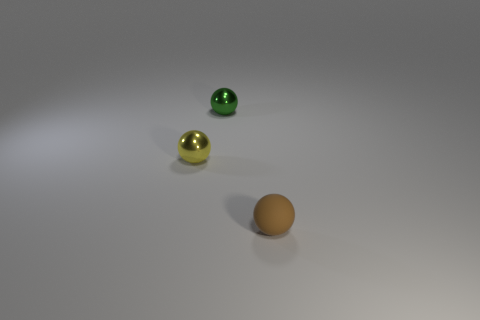Are there an equal number of tiny yellow metallic objects that are to the right of the small yellow metallic object and green objects?
Ensure brevity in your answer.  No. There is a thing that is to the left of the green ball; is it the same size as the metallic object behind the yellow shiny object?
Your answer should be compact. Yes. How many other objects are there of the same size as the matte ball?
Keep it short and to the point. 2. There is a tiny shiny object that is behind the tiny shiny ball that is to the left of the tiny green metallic object; are there any objects that are in front of it?
Keep it short and to the point. Yes. Is there anything else that is the same color as the rubber sphere?
Provide a succinct answer. No. What size is the shiny object behind the thing that is to the left of the metal ball that is behind the yellow sphere?
Provide a short and direct response. Small. What color is the shiny sphere that is behind the metallic sphere that is to the left of the green object?
Provide a short and direct response. Green. There is another small yellow thing that is the same shape as the rubber object; what material is it?
Provide a succinct answer. Metal. Are there any other things that are the same material as the small brown ball?
Your response must be concise. No. Are there any tiny green spheres behind the small brown matte ball?
Provide a succinct answer. Yes. 